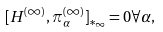<formula> <loc_0><loc_0><loc_500><loc_500>[ H ^ { ( \infty ) } , \pi _ { \alpha } ^ { ( \infty ) } ] _ { * _ { \infty } } = 0 \forall \alpha ,</formula> 